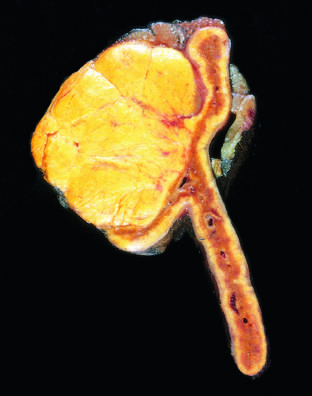what is the adenoma distinguished from?
Answer the question using a single word or phrase. Nodular hyperplasia by its solitary 